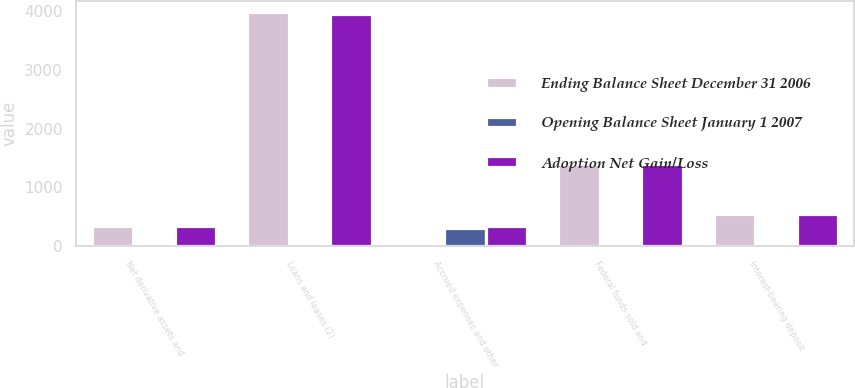Convert chart to OTSL. <chart><loc_0><loc_0><loc_500><loc_500><stacked_bar_chart><ecel><fcel>Net derivative assets and<fcel>Loans and leases (2)<fcel>Accrued expenses and other<fcel>Federal funds sold and<fcel>Interest-bearing deposit<nl><fcel>Ending Balance Sheet December 31 2006<fcel>349<fcel>3968<fcel>28<fcel>1401<fcel>548<nl><fcel>Opening Balance Sheet January 1 2007<fcel>22<fcel>21<fcel>321<fcel>1<fcel>1<nl><fcel>Adoption Net Gain/Loss<fcel>349<fcel>3947<fcel>349<fcel>1400<fcel>547<nl></chart> 